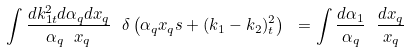Convert formula to latex. <formula><loc_0><loc_0><loc_500><loc_500>\int \frac { d k ^ { 2 } _ { 1 t } d \alpha _ { q } d x _ { q } } { \alpha _ { q } \ x _ { q } } \ \delta \left ( \alpha _ { q } x _ { q } s + ( k _ { 1 } - k _ { 2 } ) ^ { 2 } _ { t } \right ) \ = \int \frac { d \alpha _ { 1 } } { \alpha _ { q } } \ \frac { d x _ { q } } { x _ { q } }</formula> 